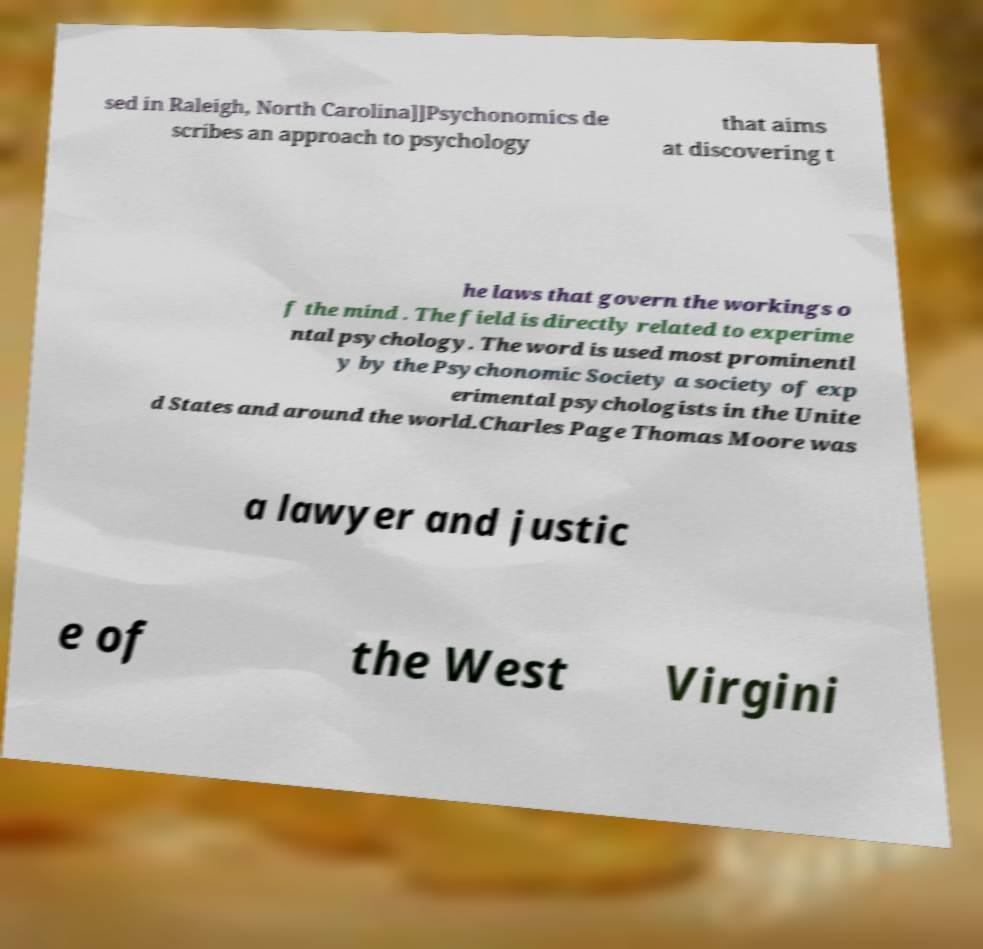Could you assist in decoding the text presented in this image and type it out clearly? sed in Raleigh, North Carolina]]Psychonomics de scribes an approach to psychology that aims at discovering t he laws that govern the workings o f the mind . The field is directly related to experime ntal psychology. The word is used most prominentl y by the Psychonomic Society a society of exp erimental psychologists in the Unite d States and around the world.Charles Page Thomas Moore was a lawyer and justic e of the West Virgini 